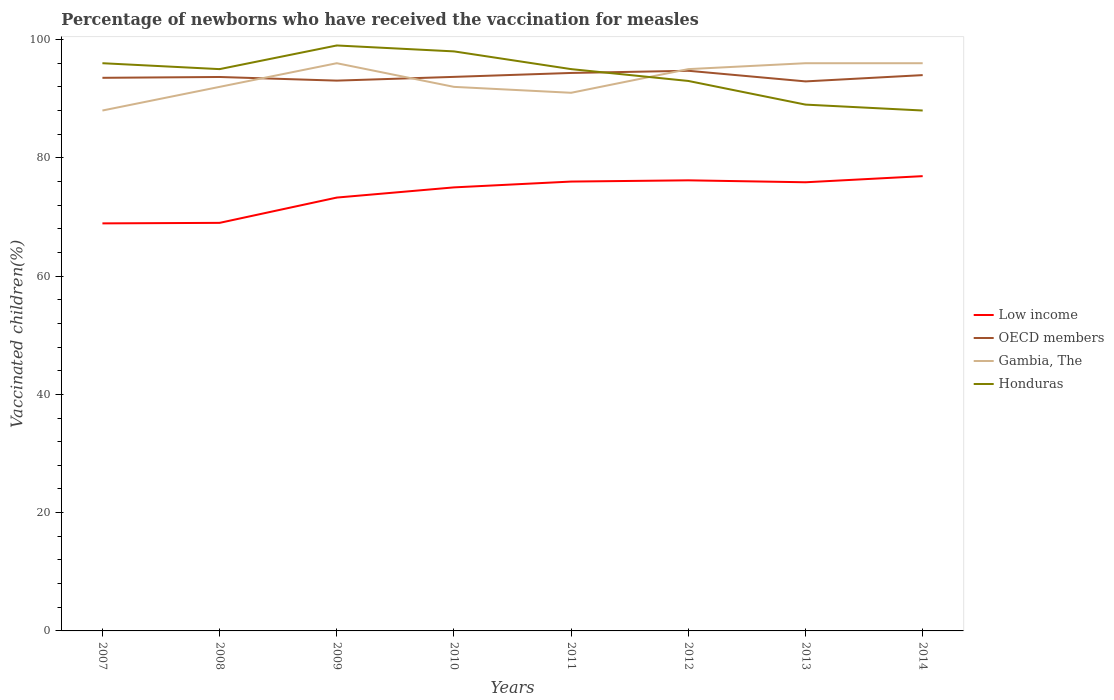How many different coloured lines are there?
Your answer should be very brief. 4. Across all years, what is the maximum percentage of vaccinated children in OECD members?
Your answer should be compact. 92.92. In which year was the percentage of vaccinated children in OECD members maximum?
Provide a short and direct response. 2013. What is the total percentage of vaccinated children in Low income in the graph?
Give a very brief answer. -6.99. What is the difference between the highest and the second highest percentage of vaccinated children in Honduras?
Give a very brief answer. 11. What is the difference between the highest and the lowest percentage of vaccinated children in Gambia, The?
Ensure brevity in your answer.  4. Is the percentage of vaccinated children in Low income strictly greater than the percentage of vaccinated children in OECD members over the years?
Keep it short and to the point. Yes. How many lines are there?
Provide a succinct answer. 4. Are the values on the major ticks of Y-axis written in scientific E-notation?
Your response must be concise. No. Where does the legend appear in the graph?
Offer a terse response. Center right. How many legend labels are there?
Your answer should be compact. 4. How are the legend labels stacked?
Give a very brief answer. Vertical. What is the title of the graph?
Offer a very short reply. Percentage of newborns who have received the vaccination for measles. What is the label or title of the X-axis?
Give a very brief answer. Years. What is the label or title of the Y-axis?
Provide a short and direct response. Vaccinated children(%). What is the Vaccinated children(%) of Low income in 2007?
Make the answer very short. 68.92. What is the Vaccinated children(%) of OECD members in 2007?
Provide a short and direct response. 93.53. What is the Vaccinated children(%) in Gambia, The in 2007?
Make the answer very short. 88. What is the Vaccinated children(%) in Honduras in 2007?
Offer a very short reply. 96. What is the Vaccinated children(%) in Low income in 2008?
Provide a succinct answer. 69. What is the Vaccinated children(%) in OECD members in 2008?
Give a very brief answer. 93.67. What is the Vaccinated children(%) in Gambia, The in 2008?
Give a very brief answer. 92. What is the Vaccinated children(%) in Honduras in 2008?
Offer a very short reply. 95. What is the Vaccinated children(%) in Low income in 2009?
Keep it short and to the point. 73.28. What is the Vaccinated children(%) in OECD members in 2009?
Your answer should be compact. 93.06. What is the Vaccinated children(%) in Gambia, The in 2009?
Keep it short and to the point. 96. What is the Vaccinated children(%) of Low income in 2010?
Your answer should be compact. 75. What is the Vaccinated children(%) in OECD members in 2010?
Your answer should be very brief. 93.69. What is the Vaccinated children(%) in Gambia, The in 2010?
Your answer should be very brief. 92. What is the Vaccinated children(%) of Low income in 2011?
Your answer should be very brief. 75.99. What is the Vaccinated children(%) of OECD members in 2011?
Your response must be concise. 94.35. What is the Vaccinated children(%) in Gambia, The in 2011?
Provide a short and direct response. 91. What is the Vaccinated children(%) of Low income in 2012?
Your answer should be very brief. 76.19. What is the Vaccinated children(%) in OECD members in 2012?
Give a very brief answer. 94.72. What is the Vaccinated children(%) in Honduras in 2012?
Your response must be concise. 93. What is the Vaccinated children(%) of Low income in 2013?
Ensure brevity in your answer.  75.87. What is the Vaccinated children(%) of OECD members in 2013?
Offer a very short reply. 92.92. What is the Vaccinated children(%) of Gambia, The in 2013?
Offer a very short reply. 96. What is the Vaccinated children(%) of Honduras in 2013?
Give a very brief answer. 89. What is the Vaccinated children(%) in Low income in 2014?
Ensure brevity in your answer.  76.9. What is the Vaccinated children(%) in OECD members in 2014?
Ensure brevity in your answer.  93.99. What is the Vaccinated children(%) in Gambia, The in 2014?
Provide a succinct answer. 96. Across all years, what is the maximum Vaccinated children(%) of Low income?
Make the answer very short. 76.9. Across all years, what is the maximum Vaccinated children(%) in OECD members?
Offer a very short reply. 94.72. Across all years, what is the maximum Vaccinated children(%) of Gambia, The?
Your response must be concise. 96. Across all years, what is the minimum Vaccinated children(%) of Low income?
Your answer should be compact. 68.92. Across all years, what is the minimum Vaccinated children(%) in OECD members?
Your answer should be compact. 92.92. What is the total Vaccinated children(%) in Low income in the graph?
Your response must be concise. 591.15. What is the total Vaccinated children(%) of OECD members in the graph?
Provide a short and direct response. 749.93. What is the total Vaccinated children(%) of Gambia, The in the graph?
Your answer should be compact. 746. What is the total Vaccinated children(%) in Honduras in the graph?
Your response must be concise. 753. What is the difference between the Vaccinated children(%) of Low income in 2007 and that in 2008?
Your response must be concise. -0.09. What is the difference between the Vaccinated children(%) of OECD members in 2007 and that in 2008?
Provide a succinct answer. -0.14. What is the difference between the Vaccinated children(%) of Low income in 2007 and that in 2009?
Make the answer very short. -4.36. What is the difference between the Vaccinated children(%) of OECD members in 2007 and that in 2009?
Give a very brief answer. 0.48. What is the difference between the Vaccinated children(%) of Gambia, The in 2007 and that in 2009?
Give a very brief answer. -8. What is the difference between the Vaccinated children(%) in Honduras in 2007 and that in 2009?
Your answer should be very brief. -3. What is the difference between the Vaccinated children(%) in Low income in 2007 and that in 2010?
Your answer should be compact. -6.09. What is the difference between the Vaccinated children(%) in OECD members in 2007 and that in 2010?
Keep it short and to the point. -0.16. What is the difference between the Vaccinated children(%) in Gambia, The in 2007 and that in 2010?
Your answer should be compact. -4. What is the difference between the Vaccinated children(%) of Low income in 2007 and that in 2011?
Provide a short and direct response. -7.07. What is the difference between the Vaccinated children(%) of OECD members in 2007 and that in 2011?
Provide a short and direct response. -0.82. What is the difference between the Vaccinated children(%) in Honduras in 2007 and that in 2011?
Ensure brevity in your answer.  1. What is the difference between the Vaccinated children(%) of Low income in 2007 and that in 2012?
Offer a very short reply. -7.28. What is the difference between the Vaccinated children(%) in OECD members in 2007 and that in 2012?
Your answer should be compact. -1.19. What is the difference between the Vaccinated children(%) in Low income in 2007 and that in 2013?
Offer a very short reply. -6.95. What is the difference between the Vaccinated children(%) in OECD members in 2007 and that in 2013?
Your answer should be very brief. 0.61. What is the difference between the Vaccinated children(%) of Low income in 2007 and that in 2014?
Your answer should be very brief. -7.99. What is the difference between the Vaccinated children(%) of OECD members in 2007 and that in 2014?
Ensure brevity in your answer.  -0.46. What is the difference between the Vaccinated children(%) of Gambia, The in 2007 and that in 2014?
Keep it short and to the point. -8. What is the difference between the Vaccinated children(%) of Honduras in 2007 and that in 2014?
Ensure brevity in your answer.  8. What is the difference between the Vaccinated children(%) of Low income in 2008 and that in 2009?
Offer a very short reply. -4.28. What is the difference between the Vaccinated children(%) of OECD members in 2008 and that in 2009?
Keep it short and to the point. 0.62. What is the difference between the Vaccinated children(%) of Gambia, The in 2008 and that in 2009?
Your answer should be very brief. -4. What is the difference between the Vaccinated children(%) of Low income in 2008 and that in 2010?
Provide a short and direct response. -6. What is the difference between the Vaccinated children(%) in OECD members in 2008 and that in 2010?
Your response must be concise. -0.02. What is the difference between the Vaccinated children(%) of Gambia, The in 2008 and that in 2010?
Keep it short and to the point. 0. What is the difference between the Vaccinated children(%) of Honduras in 2008 and that in 2010?
Your response must be concise. -3. What is the difference between the Vaccinated children(%) of Low income in 2008 and that in 2011?
Offer a very short reply. -6.99. What is the difference between the Vaccinated children(%) of OECD members in 2008 and that in 2011?
Your answer should be very brief. -0.68. What is the difference between the Vaccinated children(%) of Gambia, The in 2008 and that in 2011?
Keep it short and to the point. 1. What is the difference between the Vaccinated children(%) of Honduras in 2008 and that in 2011?
Provide a short and direct response. 0. What is the difference between the Vaccinated children(%) of Low income in 2008 and that in 2012?
Make the answer very short. -7.19. What is the difference between the Vaccinated children(%) of OECD members in 2008 and that in 2012?
Keep it short and to the point. -1.05. What is the difference between the Vaccinated children(%) of Gambia, The in 2008 and that in 2012?
Provide a short and direct response. -3. What is the difference between the Vaccinated children(%) of Low income in 2008 and that in 2013?
Make the answer very short. -6.86. What is the difference between the Vaccinated children(%) in OECD members in 2008 and that in 2013?
Ensure brevity in your answer.  0.75. What is the difference between the Vaccinated children(%) in Low income in 2008 and that in 2014?
Your response must be concise. -7.9. What is the difference between the Vaccinated children(%) in OECD members in 2008 and that in 2014?
Offer a very short reply. -0.32. What is the difference between the Vaccinated children(%) in Gambia, The in 2008 and that in 2014?
Provide a succinct answer. -4. What is the difference between the Vaccinated children(%) in Honduras in 2008 and that in 2014?
Your answer should be compact. 7. What is the difference between the Vaccinated children(%) of Low income in 2009 and that in 2010?
Your answer should be very brief. -1.72. What is the difference between the Vaccinated children(%) of OECD members in 2009 and that in 2010?
Offer a very short reply. -0.63. What is the difference between the Vaccinated children(%) of Gambia, The in 2009 and that in 2010?
Your response must be concise. 4. What is the difference between the Vaccinated children(%) in Low income in 2009 and that in 2011?
Provide a succinct answer. -2.71. What is the difference between the Vaccinated children(%) in OECD members in 2009 and that in 2011?
Ensure brevity in your answer.  -1.3. What is the difference between the Vaccinated children(%) of Gambia, The in 2009 and that in 2011?
Your response must be concise. 5. What is the difference between the Vaccinated children(%) in Honduras in 2009 and that in 2011?
Ensure brevity in your answer.  4. What is the difference between the Vaccinated children(%) in Low income in 2009 and that in 2012?
Offer a very short reply. -2.91. What is the difference between the Vaccinated children(%) of OECD members in 2009 and that in 2012?
Give a very brief answer. -1.67. What is the difference between the Vaccinated children(%) of Honduras in 2009 and that in 2012?
Offer a terse response. 6. What is the difference between the Vaccinated children(%) of Low income in 2009 and that in 2013?
Your answer should be very brief. -2.59. What is the difference between the Vaccinated children(%) in OECD members in 2009 and that in 2013?
Make the answer very short. 0.13. What is the difference between the Vaccinated children(%) of Low income in 2009 and that in 2014?
Give a very brief answer. -3.62. What is the difference between the Vaccinated children(%) in OECD members in 2009 and that in 2014?
Keep it short and to the point. -0.93. What is the difference between the Vaccinated children(%) of Low income in 2010 and that in 2011?
Ensure brevity in your answer.  -0.99. What is the difference between the Vaccinated children(%) in OECD members in 2010 and that in 2011?
Provide a succinct answer. -0.66. What is the difference between the Vaccinated children(%) in Gambia, The in 2010 and that in 2011?
Provide a short and direct response. 1. What is the difference between the Vaccinated children(%) in Low income in 2010 and that in 2012?
Offer a very short reply. -1.19. What is the difference between the Vaccinated children(%) in OECD members in 2010 and that in 2012?
Provide a succinct answer. -1.03. What is the difference between the Vaccinated children(%) of Gambia, The in 2010 and that in 2012?
Your response must be concise. -3. What is the difference between the Vaccinated children(%) of Honduras in 2010 and that in 2012?
Keep it short and to the point. 5. What is the difference between the Vaccinated children(%) of Low income in 2010 and that in 2013?
Ensure brevity in your answer.  -0.86. What is the difference between the Vaccinated children(%) of OECD members in 2010 and that in 2013?
Offer a very short reply. 0.76. What is the difference between the Vaccinated children(%) of Honduras in 2010 and that in 2013?
Your response must be concise. 9. What is the difference between the Vaccinated children(%) in Low income in 2010 and that in 2014?
Your answer should be very brief. -1.9. What is the difference between the Vaccinated children(%) of OECD members in 2010 and that in 2014?
Give a very brief answer. -0.3. What is the difference between the Vaccinated children(%) in Gambia, The in 2010 and that in 2014?
Keep it short and to the point. -4. What is the difference between the Vaccinated children(%) of Honduras in 2010 and that in 2014?
Offer a terse response. 10. What is the difference between the Vaccinated children(%) in Low income in 2011 and that in 2012?
Provide a succinct answer. -0.21. What is the difference between the Vaccinated children(%) of OECD members in 2011 and that in 2012?
Provide a short and direct response. -0.37. What is the difference between the Vaccinated children(%) of Gambia, The in 2011 and that in 2012?
Your response must be concise. -4. What is the difference between the Vaccinated children(%) in Low income in 2011 and that in 2013?
Make the answer very short. 0.12. What is the difference between the Vaccinated children(%) in OECD members in 2011 and that in 2013?
Your answer should be very brief. 1.43. What is the difference between the Vaccinated children(%) of Honduras in 2011 and that in 2013?
Your answer should be compact. 6. What is the difference between the Vaccinated children(%) in Low income in 2011 and that in 2014?
Offer a very short reply. -0.92. What is the difference between the Vaccinated children(%) of OECD members in 2011 and that in 2014?
Offer a very short reply. 0.36. What is the difference between the Vaccinated children(%) of Honduras in 2011 and that in 2014?
Give a very brief answer. 7. What is the difference between the Vaccinated children(%) of Low income in 2012 and that in 2013?
Keep it short and to the point. 0.33. What is the difference between the Vaccinated children(%) in OECD members in 2012 and that in 2013?
Your answer should be very brief. 1.8. What is the difference between the Vaccinated children(%) of Gambia, The in 2012 and that in 2013?
Give a very brief answer. -1. What is the difference between the Vaccinated children(%) in Honduras in 2012 and that in 2013?
Offer a terse response. 4. What is the difference between the Vaccinated children(%) in Low income in 2012 and that in 2014?
Your answer should be very brief. -0.71. What is the difference between the Vaccinated children(%) of OECD members in 2012 and that in 2014?
Your answer should be compact. 0.73. What is the difference between the Vaccinated children(%) of Gambia, The in 2012 and that in 2014?
Provide a succinct answer. -1. What is the difference between the Vaccinated children(%) of Honduras in 2012 and that in 2014?
Your answer should be compact. 5. What is the difference between the Vaccinated children(%) in Low income in 2013 and that in 2014?
Provide a succinct answer. -1.04. What is the difference between the Vaccinated children(%) in OECD members in 2013 and that in 2014?
Make the answer very short. -1.06. What is the difference between the Vaccinated children(%) in Honduras in 2013 and that in 2014?
Provide a succinct answer. 1. What is the difference between the Vaccinated children(%) of Low income in 2007 and the Vaccinated children(%) of OECD members in 2008?
Give a very brief answer. -24.76. What is the difference between the Vaccinated children(%) of Low income in 2007 and the Vaccinated children(%) of Gambia, The in 2008?
Your answer should be very brief. -23.08. What is the difference between the Vaccinated children(%) in Low income in 2007 and the Vaccinated children(%) in Honduras in 2008?
Keep it short and to the point. -26.08. What is the difference between the Vaccinated children(%) of OECD members in 2007 and the Vaccinated children(%) of Gambia, The in 2008?
Give a very brief answer. 1.53. What is the difference between the Vaccinated children(%) in OECD members in 2007 and the Vaccinated children(%) in Honduras in 2008?
Offer a terse response. -1.47. What is the difference between the Vaccinated children(%) of Gambia, The in 2007 and the Vaccinated children(%) of Honduras in 2008?
Your response must be concise. -7. What is the difference between the Vaccinated children(%) of Low income in 2007 and the Vaccinated children(%) of OECD members in 2009?
Provide a succinct answer. -24.14. What is the difference between the Vaccinated children(%) of Low income in 2007 and the Vaccinated children(%) of Gambia, The in 2009?
Your answer should be compact. -27.08. What is the difference between the Vaccinated children(%) in Low income in 2007 and the Vaccinated children(%) in Honduras in 2009?
Provide a succinct answer. -30.08. What is the difference between the Vaccinated children(%) in OECD members in 2007 and the Vaccinated children(%) in Gambia, The in 2009?
Your answer should be very brief. -2.47. What is the difference between the Vaccinated children(%) of OECD members in 2007 and the Vaccinated children(%) of Honduras in 2009?
Ensure brevity in your answer.  -5.47. What is the difference between the Vaccinated children(%) in Low income in 2007 and the Vaccinated children(%) in OECD members in 2010?
Ensure brevity in your answer.  -24.77. What is the difference between the Vaccinated children(%) in Low income in 2007 and the Vaccinated children(%) in Gambia, The in 2010?
Your answer should be compact. -23.08. What is the difference between the Vaccinated children(%) of Low income in 2007 and the Vaccinated children(%) of Honduras in 2010?
Offer a very short reply. -29.08. What is the difference between the Vaccinated children(%) of OECD members in 2007 and the Vaccinated children(%) of Gambia, The in 2010?
Offer a terse response. 1.53. What is the difference between the Vaccinated children(%) in OECD members in 2007 and the Vaccinated children(%) in Honduras in 2010?
Give a very brief answer. -4.47. What is the difference between the Vaccinated children(%) in Low income in 2007 and the Vaccinated children(%) in OECD members in 2011?
Offer a terse response. -25.44. What is the difference between the Vaccinated children(%) of Low income in 2007 and the Vaccinated children(%) of Gambia, The in 2011?
Provide a succinct answer. -22.08. What is the difference between the Vaccinated children(%) of Low income in 2007 and the Vaccinated children(%) of Honduras in 2011?
Provide a succinct answer. -26.08. What is the difference between the Vaccinated children(%) of OECD members in 2007 and the Vaccinated children(%) of Gambia, The in 2011?
Make the answer very short. 2.53. What is the difference between the Vaccinated children(%) in OECD members in 2007 and the Vaccinated children(%) in Honduras in 2011?
Offer a terse response. -1.47. What is the difference between the Vaccinated children(%) in Low income in 2007 and the Vaccinated children(%) in OECD members in 2012?
Your answer should be very brief. -25.81. What is the difference between the Vaccinated children(%) in Low income in 2007 and the Vaccinated children(%) in Gambia, The in 2012?
Ensure brevity in your answer.  -26.08. What is the difference between the Vaccinated children(%) of Low income in 2007 and the Vaccinated children(%) of Honduras in 2012?
Your answer should be very brief. -24.08. What is the difference between the Vaccinated children(%) of OECD members in 2007 and the Vaccinated children(%) of Gambia, The in 2012?
Your answer should be compact. -1.47. What is the difference between the Vaccinated children(%) in OECD members in 2007 and the Vaccinated children(%) in Honduras in 2012?
Your answer should be very brief. 0.53. What is the difference between the Vaccinated children(%) in Gambia, The in 2007 and the Vaccinated children(%) in Honduras in 2012?
Keep it short and to the point. -5. What is the difference between the Vaccinated children(%) of Low income in 2007 and the Vaccinated children(%) of OECD members in 2013?
Make the answer very short. -24.01. What is the difference between the Vaccinated children(%) in Low income in 2007 and the Vaccinated children(%) in Gambia, The in 2013?
Offer a very short reply. -27.08. What is the difference between the Vaccinated children(%) of Low income in 2007 and the Vaccinated children(%) of Honduras in 2013?
Your answer should be very brief. -20.08. What is the difference between the Vaccinated children(%) in OECD members in 2007 and the Vaccinated children(%) in Gambia, The in 2013?
Your answer should be compact. -2.47. What is the difference between the Vaccinated children(%) in OECD members in 2007 and the Vaccinated children(%) in Honduras in 2013?
Your answer should be very brief. 4.53. What is the difference between the Vaccinated children(%) in Low income in 2007 and the Vaccinated children(%) in OECD members in 2014?
Keep it short and to the point. -25.07. What is the difference between the Vaccinated children(%) in Low income in 2007 and the Vaccinated children(%) in Gambia, The in 2014?
Keep it short and to the point. -27.08. What is the difference between the Vaccinated children(%) of Low income in 2007 and the Vaccinated children(%) of Honduras in 2014?
Your answer should be compact. -19.08. What is the difference between the Vaccinated children(%) in OECD members in 2007 and the Vaccinated children(%) in Gambia, The in 2014?
Provide a succinct answer. -2.47. What is the difference between the Vaccinated children(%) in OECD members in 2007 and the Vaccinated children(%) in Honduras in 2014?
Ensure brevity in your answer.  5.53. What is the difference between the Vaccinated children(%) in Low income in 2008 and the Vaccinated children(%) in OECD members in 2009?
Your response must be concise. -24.05. What is the difference between the Vaccinated children(%) in Low income in 2008 and the Vaccinated children(%) in Gambia, The in 2009?
Keep it short and to the point. -27. What is the difference between the Vaccinated children(%) in Low income in 2008 and the Vaccinated children(%) in Honduras in 2009?
Ensure brevity in your answer.  -30. What is the difference between the Vaccinated children(%) in OECD members in 2008 and the Vaccinated children(%) in Gambia, The in 2009?
Your response must be concise. -2.33. What is the difference between the Vaccinated children(%) of OECD members in 2008 and the Vaccinated children(%) of Honduras in 2009?
Offer a terse response. -5.33. What is the difference between the Vaccinated children(%) of Gambia, The in 2008 and the Vaccinated children(%) of Honduras in 2009?
Ensure brevity in your answer.  -7. What is the difference between the Vaccinated children(%) of Low income in 2008 and the Vaccinated children(%) of OECD members in 2010?
Give a very brief answer. -24.69. What is the difference between the Vaccinated children(%) of Low income in 2008 and the Vaccinated children(%) of Gambia, The in 2010?
Give a very brief answer. -23. What is the difference between the Vaccinated children(%) of Low income in 2008 and the Vaccinated children(%) of Honduras in 2010?
Offer a very short reply. -29. What is the difference between the Vaccinated children(%) in OECD members in 2008 and the Vaccinated children(%) in Gambia, The in 2010?
Your answer should be compact. 1.67. What is the difference between the Vaccinated children(%) in OECD members in 2008 and the Vaccinated children(%) in Honduras in 2010?
Provide a succinct answer. -4.33. What is the difference between the Vaccinated children(%) in Gambia, The in 2008 and the Vaccinated children(%) in Honduras in 2010?
Your answer should be very brief. -6. What is the difference between the Vaccinated children(%) in Low income in 2008 and the Vaccinated children(%) in OECD members in 2011?
Give a very brief answer. -25.35. What is the difference between the Vaccinated children(%) of Low income in 2008 and the Vaccinated children(%) of Gambia, The in 2011?
Your answer should be compact. -22. What is the difference between the Vaccinated children(%) of Low income in 2008 and the Vaccinated children(%) of Honduras in 2011?
Provide a succinct answer. -26. What is the difference between the Vaccinated children(%) of OECD members in 2008 and the Vaccinated children(%) of Gambia, The in 2011?
Give a very brief answer. 2.67. What is the difference between the Vaccinated children(%) of OECD members in 2008 and the Vaccinated children(%) of Honduras in 2011?
Your answer should be very brief. -1.33. What is the difference between the Vaccinated children(%) of Gambia, The in 2008 and the Vaccinated children(%) of Honduras in 2011?
Your answer should be compact. -3. What is the difference between the Vaccinated children(%) in Low income in 2008 and the Vaccinated children(%) in OECD members in 2012?
Your answer should be compact. -25.72. What is the difference between the Vaccinated children(%) in Low income in 2008 and the Vaccinated children(%) in Gambia, The in 2012?
Offer a terse response. -26. What is the difference between the Vaccinated children(%) in Low income in 2008 and the Vaccinated children(%) in Honduras in 2012?
Your response must be concise. -24. What is the difference between the Vaccinated children(%) in OECD members in 2008 and the Vaccinated children(%) in Gambia, The in 2012?
Offer a terse response. -1.33. What is the difference between the Vaccinated children(%) of OECD members in 2008 and the Vaccinated children(%) of Honduras in 2012?
Ensure brevity in your answer.  0.67. What is the difference between the Vaccinated children(%) in Gambia, The in 2008 and the Vaccinated children(%) in Honduras in 2012?
Ensure brevity in your answer.  -1. What is the difference between the Vaccinated children(%) of Low income in 2008 and the Vaccinated children(%) of OECD members in 2013?
Your answer should be compact. -23.92. What is the difference between the Vaccinated children(%) in Low income in 2008 and the Vaccinated children(%) in Gambia, The in 2013?
Offer a very short reply. -27. What is the difference between the Vaccinated children(%) of Low income in 2008 and the Vaccinated children(%) of Honduras in 2013?
Your answer should be very brief. -20. What is the difference between the Vaccinated children(%) of OECD members in 2008 and the Vaccinated children(%) of Gambia, The in 2013?
Give a very brief answer. -2.33. What is the difference between the Vaccinated children(%) of OECD members in 2008 and the Vaccinated children(%) of Honduras in 2013?
Make the answer very short. 4.67. What is the difference between the Vaccinated children(%) in Low income in 2008 and the Vaccinated children(%) in OECD members in 2014?
Your answer should be compact. -24.99. What is the difference between the Vaccinated children(%) of Low income in 2008 and the Vaccinated children(%) of Gambia, The in 2014?
Ensure brevity in your answer.  -27. What is the difference between the Vaccinated children(%) of Low income in 2008 and the Vaccinated children(%) of Honduras in 2014?
Your answer should be compact. -19. What is the difference between the Vaccinated children(%) in OECD members in 2008 and the Vaccinated children(%) in Gambia, The in 2014?
Provide a succinct answer. -2.33. What is the difference between the Vaccinated children(%) of OECD members in 2008 and the Vaccinated children(%) of Honduras in 2014?
Provide a short and direct response. 5.67. What is the difference between the Vaccinated children(%) of Low income in 2009 and the Vaccinated children(%) of OECD members in 2010?
Your answer should be compact. -20.41. What is the difference between the Vaccinated children(%) of Low income in 2009 and the Vaccinated children(%) of Gambia, The in 2010?
Make the answer very short. -18.72. What is the difference between the Vaccinated children(%) in Low income in 2009 and the Vaccinated children(%) in Honduras in 2010?
Your response must be concise. -24.72. What is the difference between the Vaccinated children(%) in OECD members in 2009 and the Vaccinated children(%) in Gambia, The in 2010?
Provide a short and direct response. 1.06. What is the difference between the Vaccinated children(%) of OECD members in 2009 and the Vaccinated children(%) of Honduras in 2010?
Provide a succinct answer. -4.94. What is the difference between the Vaccinated children(%) in Gambia, The in 2009 and the Vaccinated children(%) in Honduras in 2010?
Offer a terse response. -2. What is the difference between the Vaccinated children(%) of Low income in 2009 and the Vaccinated children(%) of OECD members in 2011?
Provide a succinct answer. -21.07. What is the difference between the Vaccinated children(%) of Low income in 2009 and the Vaccinated children(%) of Gambia, The in 2011?
Your answer should be compact. -17.72. What is the difference between the Vaccinated children(%) in Low income in 2009 and the Vaccinated children(%) in Honduras in 2011?
Offer a terse response. -21.72. What is the difference between the Vaccinated children(%) of OECD members in 2009 and the Vaccinated children(%) of Gambia, The in 2011?
Your answer should be compact. 2.06. What is the difference between the Vaccinated children(%) of OECD members in 2009 and the Vaccinated children(%) of Honduras in 2011?
Your answer should be very brief. -1.94. What is the difference between the Vaccinated children(%) of Low income in 2009 and the Vaccinated children(%) of OECD members in 2012?
Give a very brief answer. -21.44. What is the difference between the Vaccinated children(%) of Low income in 2009 and the Vaccinated children(%) of Gambia, The in 2012?
Your response must be concise. -21.72. What is the difference between the Vaccinated children(%) of Low income in 2009 and the Vaccinated children(%) of Honduras in 2012?
Make the answer very short. -19.72. What is the difference between the Vaccinated children(%) of OECD members in 2009 and the Vaccinated children(%) of Gambia, The in 2012?
Offer a terse response. -1.94. What is the difference between the Vaccinated children(%) of OECD members in 2009 and the Vaccinated children(%) of Honduras in 2012?
Give a very brief answer. 0.06. What is the difference between the Vaccinated children(%) in Low income in 2009 and the Vaccinated children(%) in OECD members in 2013?
Provide a short and direct response. -19.64. What is the difference between the Vaccinated children(%) of Low income in 2009 and the Vaccinated children(%) of Gambia, The in 2013?
Offer a terse response. -22.72. What is the difference between the Vaccinated children(%) of Low income in 2009 and the Vaccinated children(%) of Honduras in 2013?
Offer a very short reply. -15.72. What is the difference between the Vaccinated children(%) in OECD members in 2009 and the Vaccinated children(%) in Gambia, The in 2013?
Ensure brevity in your answer.  -2.94. What is the difference between the Vaccinated children(%) of OECD members in 2009 and the Vaccinated children(%) of Honduras in 2013?
Keep it short and to the point. 4.06. What is the difference between the Vaccinated children(%) of Gambia, The in 2009 and the Vaccinated children(%) of Honduras in 2013?
Your answer should be very brief. 7. What is the difference between the Vaccinated children(%) in Low income in 2009 and the Vaccinated children(%) in OECD members in 2014?
Keep it short and to the point. -20.71. What is the difference between the Vaccinated children(%) in Low income in 2009 and the Vaccinated children(%) in Gambia, The in 2014?
Ensure brevity in your answer.  -22.72. What is the difference between the Vaccinated children(%) in Low income in 2009 and the Vaccinated children(%) in Honduras in 2014?
Keep it short and to the point. -14.72. What is the difference between the Vaccinated children(%) of OECD members in 2009 and the Vaccinated children(%) of Gambia, The in 2014?
Provide a short and direct response. -2.94. What is the difference between the Vaccinated children(%) of OECD members in 2009 and the Vaccinated children(%) of Honduras in 2014?
Your response must be concise. 5.06. What is the difference between the Vaccinated children(%) in Gambia, The in 2009 and the Vaccinated children(%) in Honduras in 2014?
Give a very brief answer. 8. What is the difference between the Vaccinated children(%) in Low income in 2010 and the Vaccinated children(%) in OECD members in 2011?
Provide a short and direct response. -19.35. What is the difference between the Vaccinated children(%) in Low income in 2010 and the Vaccinated children(%) in Gambia, The in 2011?
Keep it short and to the point. -16. What is the difference between the Vaccinated children(%) in Low income in 2010 and the Vaccinated children(%) in Honduras in 2011?
Provide a short and direct response. -20. What is the difference between the Vaccinated children(%) in OECD members in 2010 and the Vaccinated children(%) in Gambia, The in 2011?
Provide a succinct answer. 2.69. What is the difference between the Vaccinated children(%) in OECD members in 2010 and the Vaccinated children(%) in Honduras in 2011?
Your answer should be very brief. -1.31. What is the difference between the Vaccinated children(%) in Low income in 2010 and the Vaccinated children(%) in OECD members in 2012?
Provide a succinct answer. -19.72. What is the difference between the Vaccinated children(%) of Low income in 2010 and the Vaccinated children(%) of Gambia, The in 2012?
Your answer should be compact. -20. What is the difference between the Vaccinated children(%) in Low income in 2010 and the Vaccinated children(%) in Honduras in 2012?
Provide a succinct answer. -18. What is the difference between the Vaccinated children(%) in OECD members in 2010 and the Vaccinated children(%) in Gambia, The in 2012?
Make the answer very short. -1.31. What is the difference between the Vaccinated children(%) of OECD members in 2010 and the Vaccinated children(%) of Honduras in 2012?
Your answer should be compact. 0.69. What is the difference between the Vaccinated children(%) of Gambia, The in 2010 and the Vaccinated children(%) of Honduras in 2012?
Provide a succinct answer. -1. What is the difference between the Vaccinated children(%) in Low income in 2010 and the Vaccinated children(%) in OECD members in 2013?
Offer a terse response. -17.92. What is the difference between the Vaccinated children(%) in Low income in 2010 and the Vaccinated children(%) in Gambia, The in 2013?
Ensure brevity in your answer.  -21. What is the difference between the Vaccinated children(%) of Low income in 2010 and the Vaccinated children(%) of Honduras in 2013?
Provide a short and direct response. -14. What is the difference between the Vaccinated children(%) of OECD members in 2010 and the Vaccinated children(%) of Gambia, The in 2013?
Ensure brevity in your answer.  -2.31. What is the difference between the Vaccinated children(%) of OECD members in 2010 and the Vaccinated children(%) of Honduras in 2013?
Provide a succinct answer. 4.69. What is the difference between the Vaccinated children(%) of Gambia, The in 2010 and the Vaccinated children(%) of Honduras in 2013?
Ensure brevity in your answer.  3. What is the difference between the Vaccinated children(%) of Low income in 2010 and the Vaccinated children(%) of OECD members in 2014?
Your response must be concise. -18.99. What is the difference between the Vaccinated children(%) in Low income in 2010 and the Vaccinated children(%) in Gambia, The in 2014?
Keep it short and to the point. -21. What is the difference between the Vaccinated children(%) of Low income in 2010 and the Vaccinated children(%) of Honduras in 2014?
Offer a terse response. -13. What is the difference between the Vaccinated children(%) in OECD members in 2010 and the Vaccinated children(%) in Gambia, The in 2014?
Provide a succinct answer. -2.31. What is the difference between the Vaccinated children(%) of OECD members in 2010 and the Vaccinated children(%) of Honduras in 2014?
Keep it short and to the point. 5.69. What is the difference between the Vaccinated children(%) of Low income in 2011 and the Vaccinated children(%) of OECD members in 2012?
Your answer should be compact. -18.73. What is the difference between the Vaccinated children(%) of Low income in 2011 and the Vaccinated children(%) of Gambia, The in 2012?
Provide a succinct answer. -19.01. What is the difference between the Vaccinated children(%) of Low income in 2011 and the Vaccinated children(%) of Honduras in 2012?
Offer a terse response. -17.01. What is the difference between the Vaccinated children(%) in OECD members in 2011 and the Vaccinated children(%) in Gambia, The in 2012?
Keep it short and to the point. -0.65. What is the difference between the Vaccinated children(%) in OECD members in 2011 and the Vaccinated children(%) in Honduras in 2012?
Make the answer very short. 1.35. What is the difference between the Vaccinated children(%) of Low income in 2011 and the Vaccinated children(%) of OECD members in 2013?
Provide a succinct answer. -16.94. What is the difference between the Vaccinated children(%) in Low income in 2011 and the Vaccinated children(%) in Gambia, The in 2013?
Keep it short and to the point. -20.01. What is the difference between the Vaccinated children(%) of Low income in 2011 and the Vaccinated children(%) of Honduras in 2013?
Make the answer very short. -13.01. What is the difference between the Vaccinated children(%) of OECD members in 2011 and the Vaccinated children(%) of Gambia, The in 2013?
Your answer should be compact. -1.65. What is the difference between the Vaccinated children(%) in OECD members in 2011 and the Vaccinated children(%) in Honduras in 2013?
Offer a terse response. 5.35. What is the difference between the Vaccinated children(%) of Gambia, The in 2011 and the Vaccinated children(%) of Honduras in 2013?
Keep it short and to the point. 2. What is the difference between the Vaccinated children(%) in Low income in 2011 and the Vaccinated children(%) in OECD members in 2014?
Make the answer very short. -18. What is the difference between the Vaccinated children(%) in Low income in 2011 and the Vaccinated children(%) in Gambia, The in 2014?
Provide a succinct answer. -20.01. What is the difference between the Vaccinated children(%) of Low income in 2011 and the Vaccinated children(%) of Honduras in 2014?
Give a very brief answer. -12.01. What is the difference between the Vaccinated children(%) of OECD members in 2011 and the Vaccinated children(%) of Gambia, The in 2014?
Your answer should be compact. -1.65. What is the difference between the Vaccinated children(%) in OECD members in 2011 and the Vaccinated children(%) in Honduras in 2014?
Make the answer very short. 6.35. What is the difference between the Vaccinated children(%) in Low income in 2012 and the Vaccinated children(%) in OECD members in 2013?
Offer a terse response. -16.73. What is the difference between the Vaccinated children(%) of Low income in 2012 and the Vaccinated children(%) of Gambia, The in 2013?
Give a very brief answer. -19.81. What is the difference between the Vaccinated children(%) of Low income in 2012 and the Vaccinated children(%) of Honduras in 2013?
Your answer should be very brief. -12.81. What is the difference between the Vaccinated children(%) in OECD members in 2012 and the Vaccinated children(%) in Gambia, The in 2013?
Offer a terse response. -1.28. What is the difference between the Vaccinated children(%) of OECD members in 2012 and the Vaccinated children(%) of Honduras in 2013?
Offer a terse response. 5.72. What is the difference between the Vaccinated children(%) of Gambia, The in 2012 and the Vaccinated children(%) of Honduras in 2013?
Provide a succinct answer. 6. What is the difference between the Vaccinated children(%) in Low income in 2012 and the Vaccinated children(%) in OECD members in 2014?
Give a very brief answer. -17.79. What is the difference between the Vaccinated children(%) in Low income in 2012 and the Vaccinated children(%) in Gambia, The in 2014?
Provide a succinct answer. -19.81. What is the difference between the Vaccinated children(%) in Low income in 2012 and the Vaccinated children(%) in Honduras in 2014?
Offer a very short reply. -11.81. What is the difference between the Vaccinated children(%) of OECD members in 2012 and the Vaccinated children(%) of Gambia, The in 2014?
Your response must be concise. -1.28. What is the difference between the Vaccinated children(%) in OECD members in 2012 and the Vaccinated children(%) in Honduras in 2014?
Provide a short and direct response. 6.72. What is the difference between the Vaccinated children(%) in Gambia, The in 2012 and the Vaccinated children(%) in Honduras in 2014?
Give a very brief answer. 7. What is the difference between the Vaccinated children(%) of Low income in 2013 and the Vaccinated children(%) of OECD members in 2014?
Provide a short and direct response. -18.12. What is the difference between the Vaccinated children(%) of Low income in 2013 and the Vaccinated children(%) of Gambia, The in 2014?
Offer a very short reply. -20.13. What is the difference between the Vaccinated children(%) of Low income in 2013 and the Vaccinated children(%) of Honduras in 2014?
Ensure brevity in your answer.  -12.13. What is the difference between the Vaccinated children(%) in OECD members in 2013 and the Vaccinated children(%) in Gambia, The in 2014?
Offer a terse response. -3.08. What is the difference between the Vaccinated children(%) in OECD members in 2013 and the Vaccinated children(%) in Honduras in 2014?
Provide a short and direct response. 4.92. What is the difference between the Vaccinated children(%) of Gambia, The in 2013 and the Vaccinated children(%) of Honduras in 2014?
Your response must be concise. 8. What is the average Vaccinated children(%) in Low income per year?
Your answer should be compact. 73.89. What is the average Vaccinated children(%) of OECD members per year?
Provide a succinct answer. 93.74. What is the average Vaccinated children(%) of Gambia, The per year?
Your answer should be very brief. 93.25. What is the average Vaccinated children(%) in Honduras per year?
Ensure brevity in your answer.  94.12. In the year 2007, what is the difference between the Vaccinated children(%) of Low income and Vaccinated children(%) of OECD members?
Your response must be concise. -24.62. In the year 2007, what is the difference between the Vaccinated children(%) of Low income and Vaccinated children(%) of Gambia, The?
Ensure brevity in your answer.  -19.08. In the year 2007, what is the difference between the Vaccinated children(%) in Low income and Vaccinated children(%) in Honduras?
Provide a short and direct response. -27.08. In the year 2007, what is the difference between the Vaccinated children(%) in OECD members and Vaccinated children(%) in Gambia, The?
Offer a very short reply. 5.53. In the year 2007, what is the difference between the Vaccinated children(%) of OECD members and Vaccinated children(%) of Honduras?
Ensure brevity in your answer.  -2.47. In the year 2008, what is the difference between the Vaccinated children(%) of Low income and Vaccinated children(%) of OECD members?
Your response must be concise. -24.67. In the year 2008, what is the difference between the Vaccinated children(%) in Low income and Vaccinated children(%) in Gambia, The?
Offer a terse response. -23. In the year 2008, what is the difference between the Vaccinated children(%) in Low income and Vaccinated children(%) in Honduras?
Ensure brevity in your answer.  -26. In the year 2008, what is the difference between the Vaccinated children(%) of OECD members and Vaccinated children(%) of Gambia, The?
Make the answer very short. 1.67. In the year 2008, what is the difference between the Vaccinated children(%) of OECD members and Vaccinated children(%) of Honduras?
Keep it short and to the point. -1.33. In the year 2008, what is the difference between the Vaccinated children(%) in Gambia, The and Vaccinated children(%) in Honduras?
Provide a short and direct response. -3. In the year 2009, what is the difference between the Vaccinated children(%) of Low income and Vaccinated children(%) of OECD members?
Give a very brief answer. -19.78. In the year 2009, what is the difference between the Vaccinated children(%) of Low income and Vaccinated children(%) of Gambia, The?
Offer a terse response. -22.72. In the year 2009, what is the difference between the Vaccinated children(%) of Low income and Vaccinated children(%) of Honduras?
Your answer should be very brief. -25.72. In the year 2009, what is the difference between the Vaccinated children(%) in OECD members and Vaccinated children(%) in Gambia, The?
Make the answer very short. -2.94. In the year 2009, what is the difference between the Vaccinated children(%) in OECD members and Vaccinated children(%) in Honduras?
Ensure brevity in your answer.  -5.94. In the year 2009, what is the difference between the Vaccinated children(%) in Gambia, The and Vaccinated children(%) in Honduras?
Offer a very short reply. -3. In the year 2010, what is the difference between the Vaccinated children(%) in Low income and Vaccinated children(%) in OECD members?
Provide a short and direct response. -18.69. In the year 2010, what is the difference between the Vaccinated children(%) of Low income and Vaccinated children(%) of Gambia, The?
Give a very brief answer. -17. In the year 2010, what is the difference between the Vaccinated children(%) in Low income and Vaccinated children(%) in Honduras?
Ensure brevity in your answer.  -23. In the year 2010, what is the difference between the Vaccinated children(%) in OECD members and Vaccinated children(%) in Gambia, The?
Ensure brevity in your answer.  1.69. In the year 2010, what is the difference between the Vaccinated children(%) of OECD members and Vaccinated children(%) of Honduras?
Provide a succinct answer. -4.31. In the year 2011, what is the difference between the Vaccinated children(%) in Low income and Vaccinated children(%) in OECD members?
Your response must be concise. -18.36. In the year 2011, what is the difference between the Vaccinated children(%) in Low income and Vaccinated children(%) in Gambia, The?
Provide a succinct answer. -15.01. In the year 2011, what is the difference between the Vaccinated children(%) of Low income and Vaccinated children(%) of Honduras?
Provide a short and direct response. -19.01. In the year 2011, what is the difference between the Vaccinated children(%) in OECD members and Vaccinated children(%) in Gambia, The?
Your response must be concise. 3.35. In the year 2011, what is the difference between the Vaccinated children(%) in OECD members and Vaccinated children(%) in Honduras?
Give a very brief answer. -0.65. In the year 2012, what is the difference between the Vaccinated children(%) in Low income and Vaccinated children(%) in OECD members?
Your answer should be compact. -18.53. In the year 2012, what is the difference between the Vaccinated children(%) in Low income and Vaccinated children(%) in Gambia, The?
Offer a terse response. -18.81. In the year 2012, what is the difference between the Vaccinated children(%) in Low income and Vaccinated children(%) in Honduras?
Give a very brief answer. -16.81. In the year 2012, what is the difference between the Vaccinated children(%) in OECD members and Vaccinated children(%) in Gambia, The?
Provide a short and direct response. -0.28. In the year 2012, what is the difference between the Vaccinated children(%) of OECD members and Vaccinated children(%) of Honduras?
Your answer should be compact. 1.72. In the year 2012, what is the difference between the Vaccinated children(%) of Gambia, The and Vaccinated children(%) of Honduras?
Offer a very short reply. 2. In the year 2013, what is the difference between the Vaccinated children(%) of Low income and Vaccinated children(%) of OECD members?
Offer a very short reply. -17.06. In the year 2013, what is the difference between the Vaccinated children(%) of Low income and Vaccinated children(%) of Gambia, The?
Ensure brevity in your answer.  -20.13. In the year 2013, what is the difference between the Vaccinated children(%) in Low income and Vaccinated children(%) in Honduras?
Your response must be concise. -13.13. In the year 2013, what is the difference between the Vaccinated children(%) in OECD members and Vaccinated children(%) in Gambia, The?
Offer a terse response. -3.08. In the year 2013, what is the difference between the Vaccinated children(%) in OECD members and Vaccinated children(%) in Honduras?
Give a very brief answer. 3.92. In the year 2014, what is the difference between the Vaccinated children(%) in Low income and Vaccinated children(%) in OECD members?
Ensure brevity in your answer.  -17.08. In the year 2014, what is the difference between the Vaccinated children(%) of Low income and Vaccinated children(%) of Gambia, The?
Your answer should be very brief. -19.1. In the year 2014, what is the difference between the Vaccinated children(%) of Low income and Vaccinated children(%) of Honduras?
Ensure brevity in your answer.  -11.1. In the year 2014, what is the difference between the Vaccinated children(%) of OECD members and Vaccinated children(%) of Gambia, The?
Ensure brevity in your answer.  -2.01. In the year 2014, what is the difference between the Vaccinated children(%) of OECD members and Vaccinated children(%) of Honduras?
Offer a very short reply. 5.99. What is the ratio of the Vaccinated children(%) in Gambia, The in 2007 to that in 2008?
Provide a succinct answer. 0.96. What is the ratio of the Vaccinated children(%) of Honduras in 2007 to that in 2008?
Make the answer very short. 1.01. What is the ratio of the Vaccinated children(%) in Low income in 2007 to that in 2009?
Offer a terse response. 0.94. What is the ratio of the Vaccinated children(%) in Honduras in 2007 to that in 2009?
Your response must be concise. 0.97. What is the ratio of the Vaccinated children(%) in Low income in 2007 to that in 2010?
Your response must be concise. 0.92. What is the ratio of the Vaccinated children(%) in Gambia, The in 2007 to that in 2010?
Your response must be concise. 0.96. What is the ratio of the Vaccinated children(%) of Honduras in 2007 to that in 2010?
Your response must be concise. 0.98. What is the ratio of the Vaccinated children(%) of Low income in 2007 to that in 2011?
Offer a very short reply. 0.91. What is the ratio of the Vaccinated children(%) in Gambia, The in 2007 to that in 2011?
Keep it short and to the point. 0.97. What is the ratio of the Vaccinated children(%) of Honduras in 2007 to that in 2011?
Offer a terse response. 1.01. What is the ratio of the Vaccinated children(%) of Low income in 2007 to that in 2012?
Provide a short and direct response. 0.9. What is the ratio of the Vaccinated children(%) in OECD members in 2007 to that in 2012?
Offer a terse response. 0.99. What is the ratio of the Vaccinated children(%) of Gambia, The in 2007 to that in 2012?
Offer a very short reply. 0.93. What is the ratio of the Vaccinated children(%) in Honduras in 2007 to that in 2012?
Your answer should be compact. 1.03. What is the ratio of the Vaccinated children(%) in Low income in 2007 to that in 2013?
Offer a very short reply. 0.91. What is the ratio of the Vaccinated children(%) in OECD members in 2007 to that in 2013?
Your answer should be very brief. 1.01. What is the ratio of the Vaccinated children(%) of Gambia, The in 2007 to that in 2013?
Provide a succinct answer. 0.92. What is the ratio of the Vaccinated children(%) in Honduras in 2007 to that in 2013?
Give a very brief answer. 1.08. What is the ratio of the Vaccinated children(%) of Low income in 2007 to that in 2014?
Provide a short and direct response. 0.9. What is the ratio of the Vaccinated children(%) of Honduras in 2007 to that in 2014?
Keep it short and to the point. 1.09. What is the ratio of the Vaccinated children(%) of Low income in 2008 to that in 2009?
Ensure brevity in your answer.  0.94. What is the ratio of the Vaccinated children(%) in OECD members in 2008 to that in 2009?
Offer a very short reply. 1.01. What is the ratio of the Vaccinated children(%) in Gambia, The in 2008 to that in 2009?
Provide a succinct answer. 0.96. What is the ratio of the Vaccinated children(%) in Honduras in 2008 to that in 2009?
Offer a terse response. 0.96. What is the ratio of the Vaccinated children(%) of Honduras in 2008 to that in 2010?
Your answer should be compact. 0.97. What is the ratio of the Vaccinated children(%) in Low income in 2008 to that in 2011?
Your response must be concise. 0.91. What is the ratio of the Vaccinated children(%) of Low income in 2008 to that in 2012?
Provide a succinct answer. 0.91. What is the ratio of the Vaccinated children(%) of OECD members in 2008 to that in 2012?
Provide a short and direct response. 0.99. What is the ratio of the Vaccinated children(%) of Gambia, The in 2008 to that in 2012?
Your answer should be very brief. 0.97. What is the ratio of the Vaccinated children(%) of Honduras in 2008 to that in 2012?
Give a very brief answer. 1.02. What is the ratio of the Vaccinated children(%) of Low income in 2008 to that in 2013?
Offer a terse response. 0.91. What is the ratio of the Vaccinated children(%) of Gambia, The in 2008 to that in 2013?
Keep it short and to the point. 0.96. What is the ratio of the Vaccinated children(%) in Honduras in 2008 to that in 2013?
Keep it short and to the point. 1.07. What is the ratio of the Vaccinated children(%) of Low income in 2008 to that in 2014?
Ensure brevity in your answer.  0.9. What is the ratio of the Vaccinated children(%) of Gambia, The in 2008 to that in 2014?
Your answer should be compact. 0.96. What is the ratio of the Vaccinated children(%) of Honduras in 2008 to that in 2014?
Your answer should be compact. 1.08. What is the ratio of the Vaccinated children(%) of Low income in 2009 to that in 2010?
Provide a succinct answer. 0.98. What is the ratio of the Vaccinated children(%) of Gambia, The in 2009 to that in 2010?
Your response must be concise. 1.04. What is the ratio of the Vaccinated children(%) in Honduras in 2009 to that in 2010?
Keep it short and to the point. 1.01. What is the ratio of the Vaccinated children(%) of Low income in 2009 to that in 2011?
Your response must be concise. 0.96. What is the ratio of the Vaccinated children(%) in OECD members in 2009 to that in 2011?
Make the answer very short. 0.99. What is the ratio of the Vaccinated children(%) of Gambia, The in 2009 to that in 2011?
Give a very brief answer. 1.05. What is the ratio of the Vaccinated children(%) of Honduras in 2009 to that in 2011?
Provide a succinct answer. 1.04. What is the ratio of the Vaccinated children(%) in Low income in 2009 to that in 2012?
Give a very brief answer. 0.96. What is the ratio of the Vaccinated children(%) in OECD members in 2009 to that in 2012?
Keep it short and to the point. 0.98. What is the ratio of the Vaccinated children(%) in Gambia, The in 2009 to that in 2012?
Provide a succinct answer. 1.01. What is the ratio of the Vaccinated children(%) in Honduras in 2009 to that in 2012?
Make the answer very short. 1.06. What is the ratio of the Vaccinated children(%) in Low income in 2009 to that in 2013?
Provide a succinct answer. 0.97. What is the ratio of the Vaccinated children(%) of Gambia, The in 2009 to that in 2013?
Offer a very short reply. 1. What is the ratio of the Vaccinated children(%) in Honduras in 2009 to that in 2013?
Give a very brief answer. 1.11. What is the ratio of the Vaccinated children(%) in Low income in 2009 to that in 2014?
Your response must be concise. 0.95. What is the ratio of the Vaccinated children(%) in Low income in 2010 to that in 2011?
Give a very brief answer. 0.99. What is the ratio of the Vaccinated children(%) in Honduras in 2010 to that in 2011?
Provide a short and direct response. 1.03. What is the ratio of the Vaccinated children(%) of Low income in 2010 to that in 2012?
Your answer should be very brief. 0.98. What is the ratio of the Vaccinated children(%) in OECD members in 2010 to that in 2012?
Keep it short and to the point. 0.99. What is the ratio of the Vaccinated children(%) of Gambia, The in 2010 to that in 2012?
Give a very brief answer. 0.97. What is the ratio of the Vaccinated children(%) of Honduras in 2010 to that in 2012?
Keep it short and to the point. 1.05. What is the ratio of the Vaccinated children(%) in Low income in 2010 to that in 2013?
Give a very brief answer. 0.99. What is the ratio of the Vaccinated children(%) in OECD members in 2010 to that in 2013?
Your response must be concise. 1.01. What is the ratio of the Vaccinated children(%) of Gambia, The in 2010 to that in 2013?
Keep it short and to the point. 0.96. What is the ratio of the Vaccinated children(%) of Honduras in 2010 to that in 2013?
Your response must be concise. 1.1. What is the ratio of the Vaccinated children(%) of Low income in 2010 to that in 2014?
Give a very brief answer. 0.98. What is the ratio of the Vaccinated children(%) in OECD members in 2010 to that in 2014?
Give a very brief answer. 1. What is the ratio of the Vaccinated children(%) of Gambia, The in 2010 to that in 2014?
Your answer should be very brief. 0.96. What is the ratio of the Vaccinated children(%) of Honduras in 2010 to that in 2014?
Make the answer very short. 1.11. What is the ratio of the Vaccinated children(%) in Gambia, The in 2011 to that in 2012?
Your response must be concise. 0.96. What is the ratio of the Vaccinated children(%) in Honduras in 2011 to that in 2012?
Offer a very short reply. 1.02. What is the ratio of the Vaccinated children(%) in Low income in 2011 to that in 2013?
Give a very brief answer. 1. What is the ratio of the Vaccinated children(%) in OECD members in 2011 to that in 2013?
Give a very brief answer. 1.02. What is the ratio of the Vaccinated children(%) in Gambia, The in 2011 to that in 2013?
Offer a terse response. 0.95. What is the ratio of the Vaccinated children(%) of Honduras in 2011 to that in 2013?
Your answer should be very brief. 1.07. What is the ratio of the Vaccinated children(%) of Low income in 2011 to that in 2014?
Your answer should be compact. 0.99. What is the ratio of the Vaccinated children(%) in Gambia, The in 2011 to that in 2014?
Offer a very short reply. 0.95. What is the ratio of the Vaccinated children(%) in Honduras in 2011 to that in 2014?
Offer a very short reply. 1.08. What is the ratio of the Vaccinated children(%) in OECD members in 2012 to that in 2013?
Make the answer very short. 1.02. What is the ratio of the Vaccinated children(%) in Gambia, The in 2012 to that in 2013?
Your answer should be compact. 0.99. What is the ratio of the Vaccinated children(%) in Honduras in 2012 to that in 2013?
Offer a terse response. 1.04. What is the ratio of the Vaccinated children(%) of Low income in 2012 to that in 2014?
Make the answer very short. 0.99. What is the ratio of the Vaccinated children(%) in OECD members in 2012 to that in 2014?
Provide a short and direct response. 1.01. What is the ratio of the Vaccinated children(%) in Gambia, The in 2012 to that in 2014?
Ensure brevity in your answer.  0.99. What is the ratio of the Vaccinated children(%) in Honduras in 2012 to that in 2014?
Ensure brevity in your answer.  1.06. What is the ratio of the Vaccinated children(%) of Low income in 2013 to that in 2014?
Provide a short and direct response. 0.99. What is the ratio of the Vaccinated children(%) of OECD members in 2013 to that in 2014?
Your answer should be compact. 0.99. What is the ratio of the Vaccinated children(%) of Gambia, The in 2013 to that in 2014?
Your response must be concise. 1. What is the ratio of the Vaccinated children(%) of Honduras in 2013 to that in 2014?
Provide a short and direct response. 1.01. What is the difference between the highest and the second highest Vaccinated children(%) of Low income?
Give a very brief answer. 0.71. What is the difference between the highest and the second highest Vaccinated children(%) of OECD members?
Keep it short and to the point. 0.37. What is the difference between the highest and the second highest Vaccinated children(%) in Gambia, The?
Your answer should be very brief. 0. What is the difference between the highest and the second highest Vaccinated children(%) in Honduras?
Provide a succinct answer. 1. What is the difference between the highest and the lowest Vaccinated children(%) in Low income?
Offer a very short reply. 7.99. What is the difference between the highest and the lowest Vaccinated children(%) in OECD members?
Offer a terse response. 1.8. What is the difference between the highest and the lowest Vaccinated children(%) of Gambia, The?
Your answer should be compact. 8. What is the difference between the highest and the lowest Vaccinated children(%) of Honduras?
Provide a succinct answer. 11. 